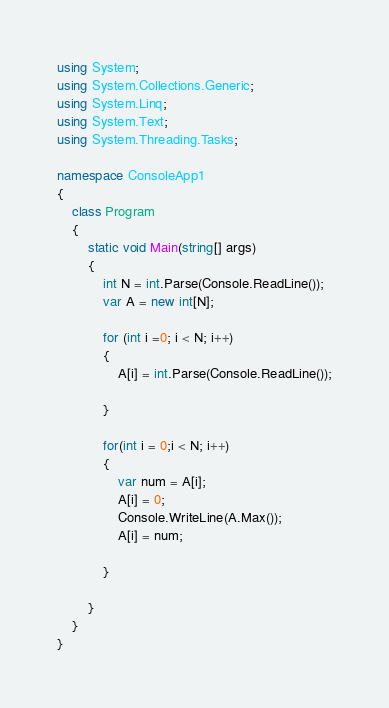Convert code to text. <code><loc_0><loc_0><loc_500><loc_500><_C#_>using System;
using System.Collections.Generic;
using System.Linq;
using System.Text;
using System.Threading.Tasks;

namespace ConsoleApp1
{
    class Program
    {
        static void Main(string[] args)
        {
            int N = int.Parse(Console.ReadLine());
            var A = new int[N];

            for (int i =0; i < N; i++)
            {
                A[i] = int.Parse(Console.ReadLine());

            }

            for(int i = 0;i < N; i++)
            {
                var num = A[i];
                A[i] = 0;
                Console.WriteLine(A.Max());
                A[i] = num;

            }

        }
    }
}
</code> 